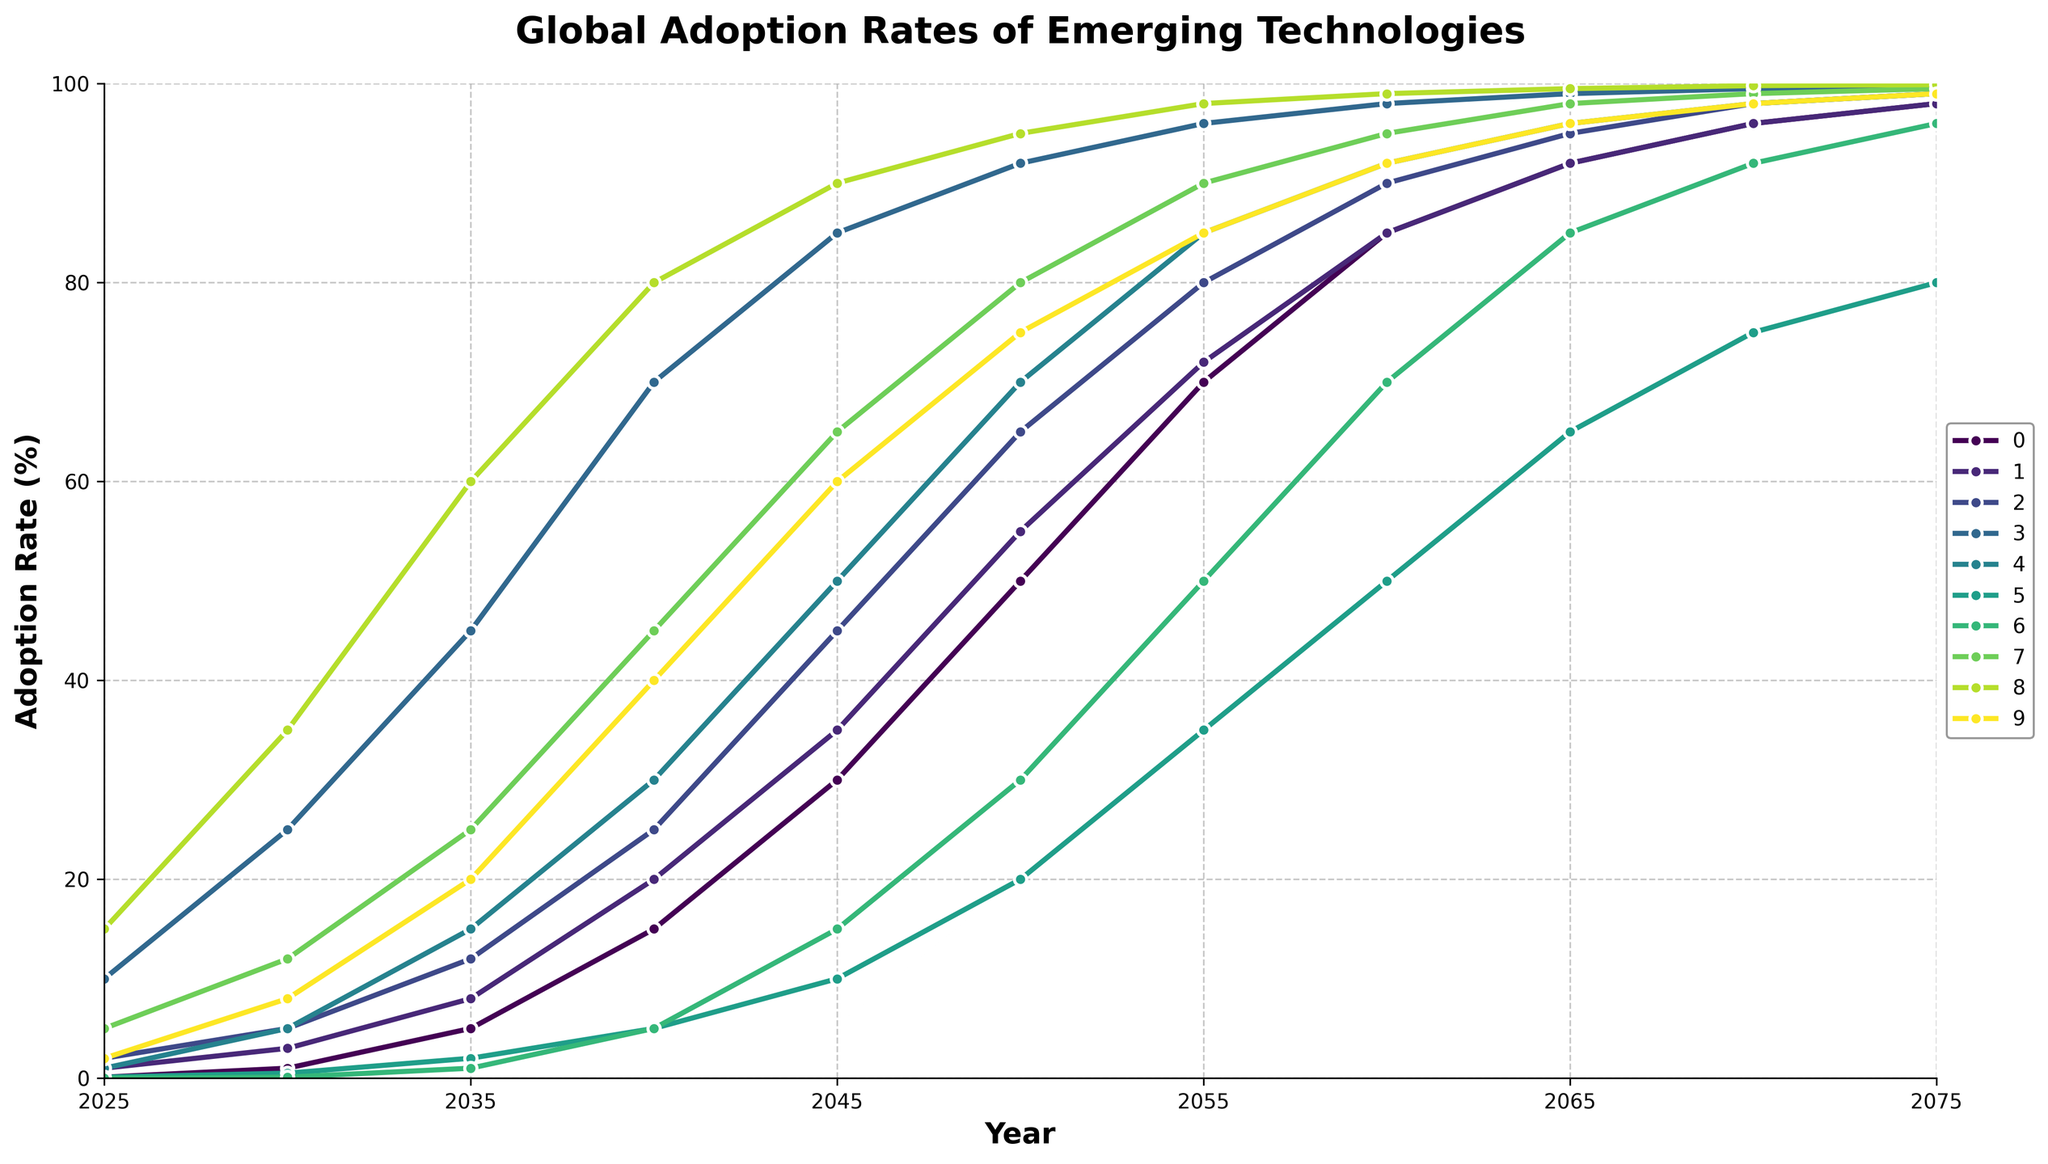Which technology has the highest adoption rate in 2050? Identify the technology with the highest value along the adoption rate axis for the year 2050. Virtual Reality has the highest adoption rate in 2050 at 95%.
Answer: Virtual Reality By how many percentage points does the adoption rate of Brain-Computer Interfaces increase from 2025 to 2050? Subtract the adoption rate of Brain-Computer Interfaces in 2025 from that in 2050: 55% - 1% = 54%.
Answer: 54 Which two technologies reach an adoption rate of 99% or higher first? Observe the points where the adoption rate hits 99% across all technologies and determine which two reach this point the earliest. Nanotechnology and Virtual Reality both reach 99% by 2070.
Answer: Nanotechnology, Virtual Reality How does the adoption rate of Fusion Energy in 2075 compare to that of Space Tourism in the same year? Check the adoption rates for both Fusion Energy and Space Tourism in the year 2075 and compare their values. Fusion Energy reaches 96%, while Space Tourism reaches 80% in 2075.
Answer: Fusion Energy is higher What is the average adoption rate of Quantum Computing over the years 2035, 2040, and 2045? Add the adoption rates of Quantum Computing in the years 2035, 2040, and 2045 and divide by 3 to find the average: (12 + 25 + 45) / 3 = 27.33%.
Answer: 27.33 Which technology typically has a faster rate of increase in adoption from 2025 to 2050, Artificial General Intelligence or Gene Editing? Compare the increase in adoption rates for Artificial General Intelligence and Gene Editing between 2025 and 2050. AGI increases from 0.1% to 50%, while Gene Editing increases from 2% to 75%. Both start with low adoption, but Gene Editing shows a more significant increase.
Answer: Gene Editing From 2025 to 2075, which technology shows the most consistent growth (i.e., least fluctuation in the growth rate)? By visually inspecting the slopes of the lines, determine which line shows the steadiest upward trajectory without major changes in growth rate. Virtual Reality exhibits a steady growth trajectory from 2025 to 2075.
Answer: Virtual Reality What is the difference in adoption rate of Autonomous Vehicles between 2030 and 2050? Subtract the adoption rate of Autonomous Vehicles in 2030 from that in 2050: 92% - 25% = 67%.
Answer: 67 In what year does Brain-Computer Interfaces surpass the 50% adoption rate? Identify the first year in which the adoption rate for Brain-Computer Interfaces exceeds 50%. This occurs in 2045.
Answer: 2045 What is the median adoption rate of 3D Printed Organs in the years 2025, 2035, 2045, 2055, and 2075? Arrange the adoption rates of 3D Printed Organs for the given years and find the middle value: 1, 15, 50, 85, 99. The median value is 50%.
Answer: 50 